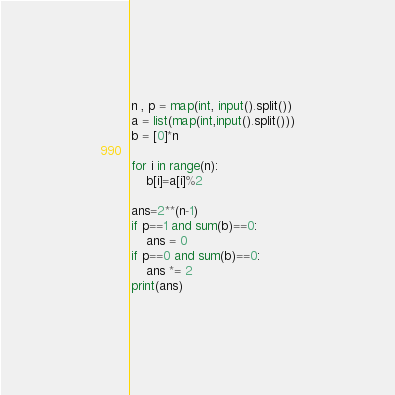Convert code to text. <code><loc_0><loc_0><loc_500><loc_500><_Python_>n , p = map(int, input().split())
a = list(map(int,input().split()))
b = [0]*n

for i in range(n):
    b[i]=a[i]%2

ans=2**(n-1)
if p==1 and sum(b)==0:
    ans = 0
if p==0 and sum(b)==0:
    ans *= 2
print(ans)
</code> 